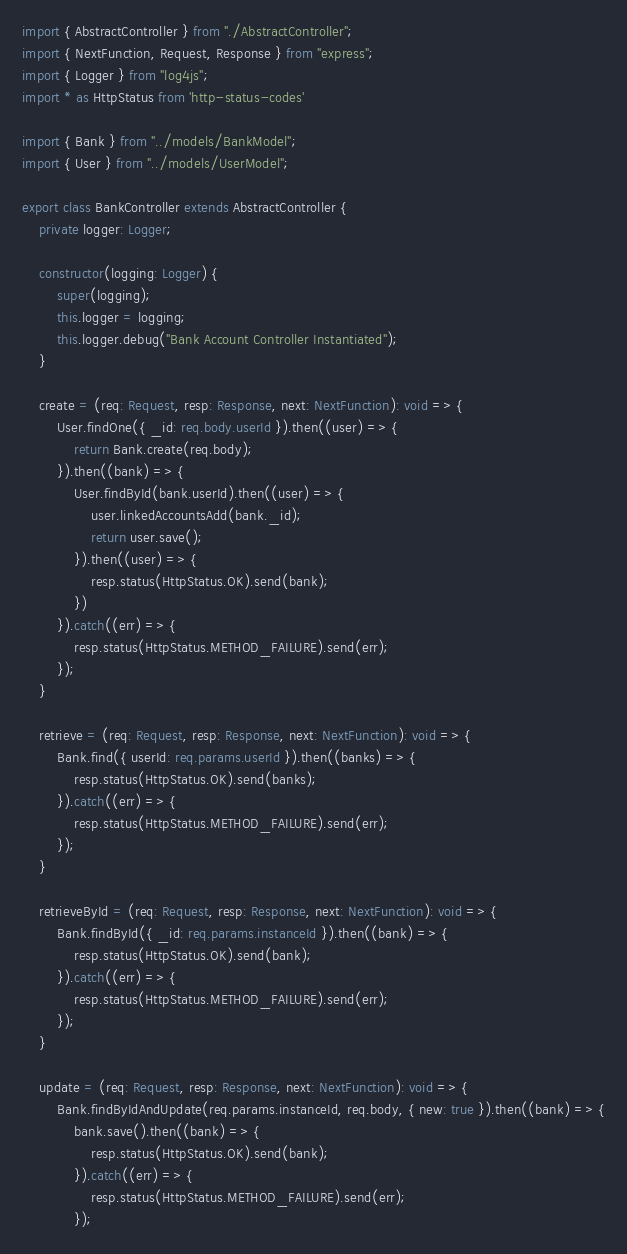<code> <loc_0><loc_0><loc_500><loc_500><_TypeScript_>import { AbstractController } from "./AbstractController";
import { NextFunction, Request, Response } from "express";
import { Logger } from "log4js";
import * as HttpStatus from 'http-status-codes'

import { Bank } from "../models/BankModel";
import { User } from "../models/UserModel";

export class BankController extends AbstractController {
    private logger: Logger;

    constructor(logging: Logger) {
        super(logging);
        this.logger = logging;
        this.logger.debug("Bank Account Controller Instantiated");
    }

    create = (req: Request, resp: Response, next: NextFunction): void => {
        User.findOne({ _id: req.body.userId }).then((user) => {
            return Bank.create(req.body);
        }).then((bank) => {
            User.findById(bank.userId).then((user) => {
                user.linkedAccountsAdd(bank._id);
                return user.save();
            }).then((user) => {
                resp.status(HttpStatus.OK).send(bank);
            })
        }).catch((err) => {
            resp.status(HttpStatus.METHOD_FAILURE).send(err);
        });
    }

    retrieve = (req: Request, resp: Response, next: NextFunction): void => {
        Bank.find({ userId: req.params.userId }).then((banks) => {
            resp.status(HttpStatus.OK).send(banks);
        }).catch((err) => {
            resp.status(HttpStatus.METHOD_FAILURE).send(err);
        });
    }

    retrieveById = (req: Request, resp: Response, next: NextFunction): void => {
        Bank.findById({ _id: req.params.instanceId }).then((bank) => {
            resp.status(HttpStatus.OK).send(bank);
        }).catch((err) => {
            resp.status(HttpStatus.METHOD_FAILURE).send(err);
        });
    }

    update = (req: Request, resp: Response, next: NextFunction): void => {
        Bank.findByIdAndUpdate(req.params.instanceId, req.body, { new: true }).then((bank) => {
            bank.save().then((bank) => {
                resp.status(HttpStatus.OK).send(bank);
            }).catch((err) => {
                resp.status(HttpStatus.METHOD_FAILURE).send(err);
            });</code> 